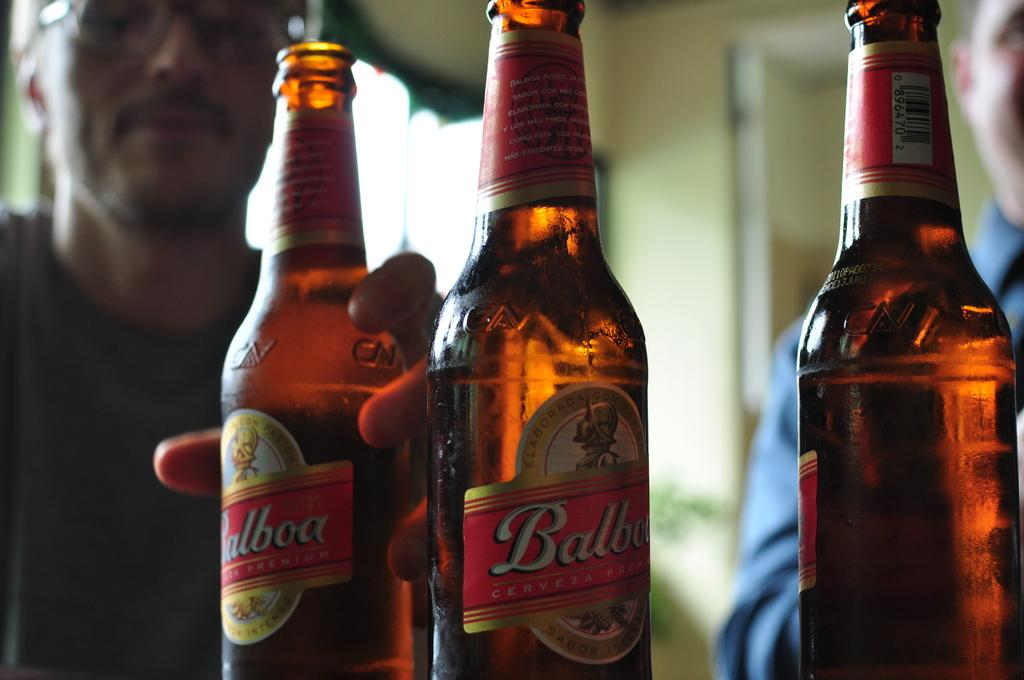<image>
Render a clear and concise summary of the photo. A man holding a beer glass for Balboa 